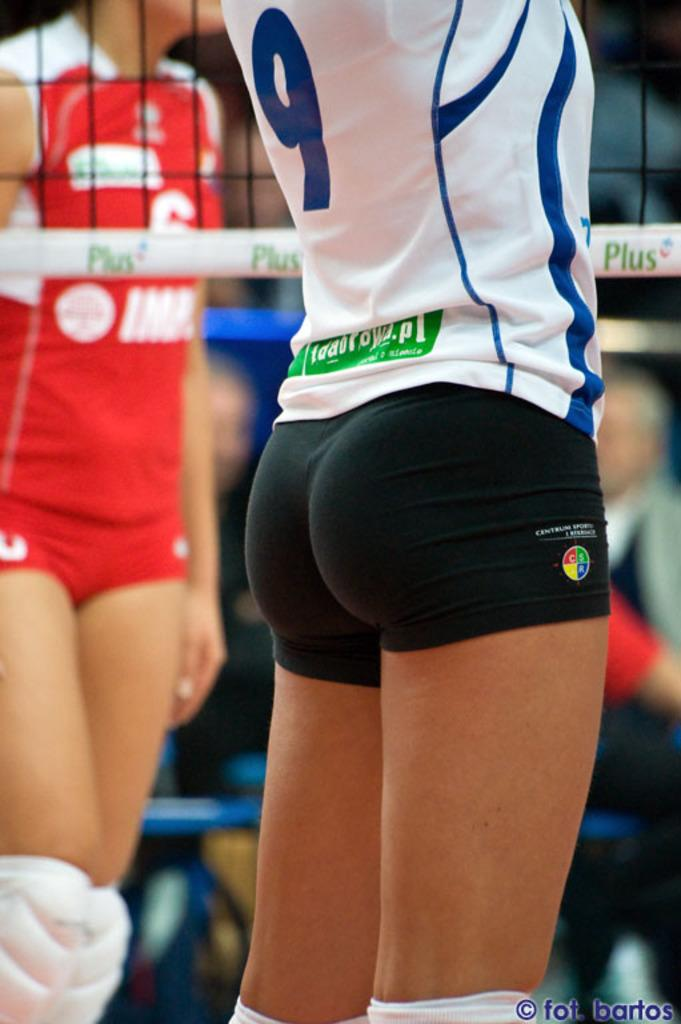How many people are present in the image? There are two persons standing in the image. What object can be seen in the image? There is a net in the image. Can you describe the people in the background of the image? The people in the background are blurry, making it difficult to provide a detailed description. What type of popcorn is being smashed by the bean in the image? There is no popcorn or bean present in the image. 